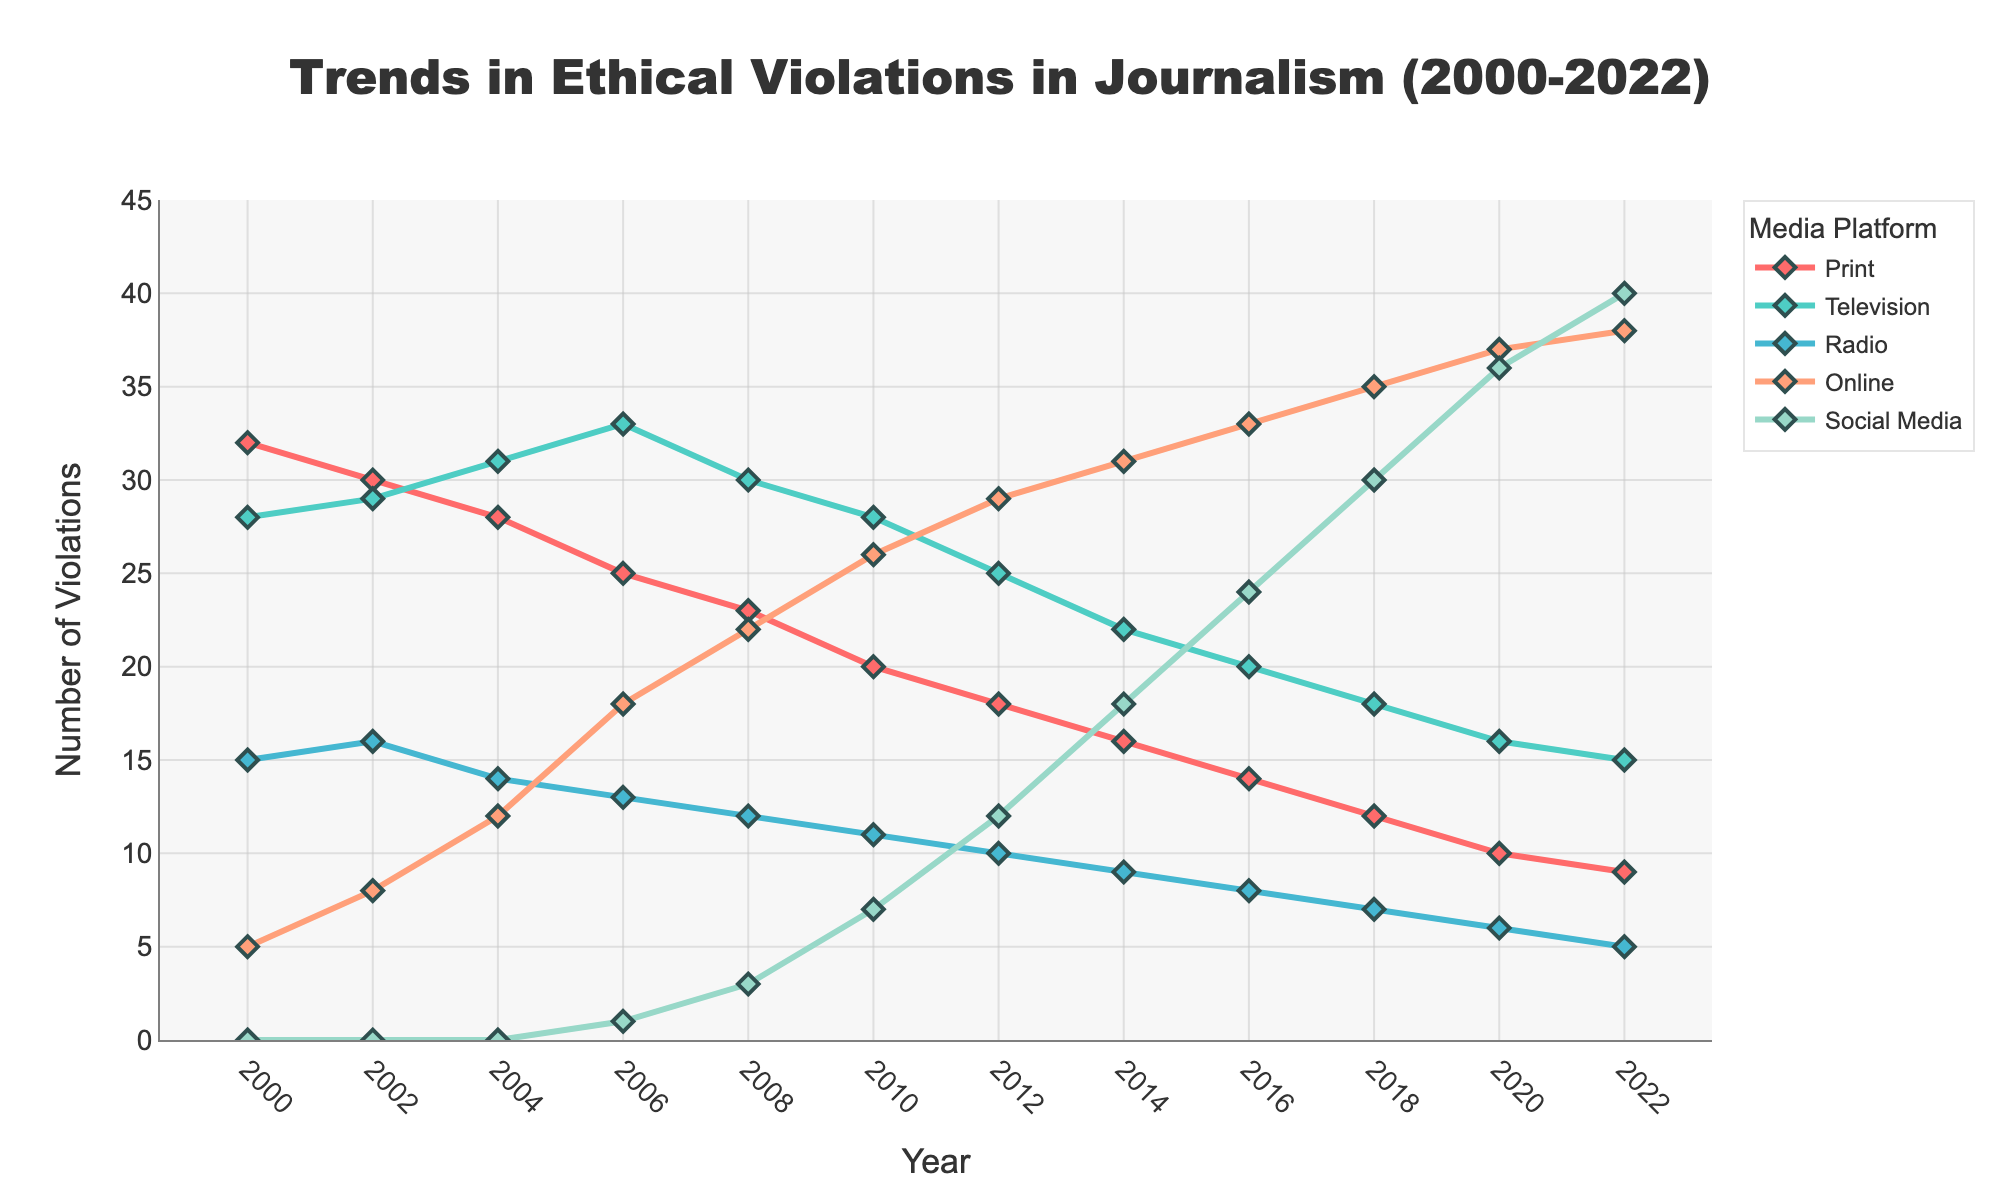What was the trend in ethical violations in print journalism from 2000 to 2022? From the figure, we observe that the number of ethical violations in print journalism steadily declined over the years, starting from 32 in 2000 to 9 in 2022. This indicates a clear downward trend.
Answer: Downward trend In which year did online media first surpass print media in ethical violations? By examining the lines on the chart, we see that online media first surpasses print media in ethical violations between 2004 and 2006. Specifically, in 2006, online media had 18 violations while print had 25.
Answer: 2006 Compare the number of ethical violations in television and social media in 2020. In 2020, from the chart, the number of ethical violations in television is 16 while in social media, it is 36. We can compare and see that social media had more than double the violations of television.
Answer: Social media had more What was the average number of ethical violations in radio across the years given? The values for radio are 15, 16, 14, 13, 12, 11, 10, 9, 8, 7, 6, and 5. Summing these up gives 126, and there are 12 data points. The average is 126/12 = 10.5.
Answer: 10.5 Which media platform had the largest increase in ethical violations between 2006 and 2022? To determine this, we compare the violations in 2006 to those in 2022 for each platform: Print (25 to 9), Television (33 to 15), Radio (13 to 5), Online (18 to 38), Social Media (1 to 40). Social media saw the largest increase of 39 violations.
Answer: Social Media What was the difference in ethical violations between the highest and lowest platforms in 2018? In 2018, the ethical violations are: Print (12), Television (18), Radio (7), Online (35), Social Media (30). The highest is Online with 35 and the lowest is Radio with 7. The difference is 35 - 7 = 28.
Answer: 28 How did the number of ethical violations in online media change from 2006 to 2014? Looking at the chart, online media had 18 violations in 2006 and 31 in 2014. The change is 31 - 18 = 13. This shows an increase of 13 violations.
Answer: Increased by 13 Was there any year where the number of violations in radio significantly deviated from its general trend? Observing the line representing radio violations, while there is a general downward trend, no specific year shows a significant deviation from this trend. The decline appears steady and consistent.
Answer: No significant deviation 